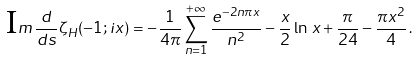Convert formula to latex. <formula><loc_0><loc_0><loc_500><loc_500>\mbox I m \, \frac { d } { d s } \zeta _ { H } ( - 1 ; i x ) = - \frac { 1 } { 4 \pi } \sum _ { n = 1 } ^ { + \infty } \frac { e ^ { - 2 n \pi x } } { n ^ { 2 } } - \frac { x } { 2 } \ln \, x + \frac { \pi } { 2 4 } - \frac { \pi x ^ { 2 } } { 4 } \, .</formula> 